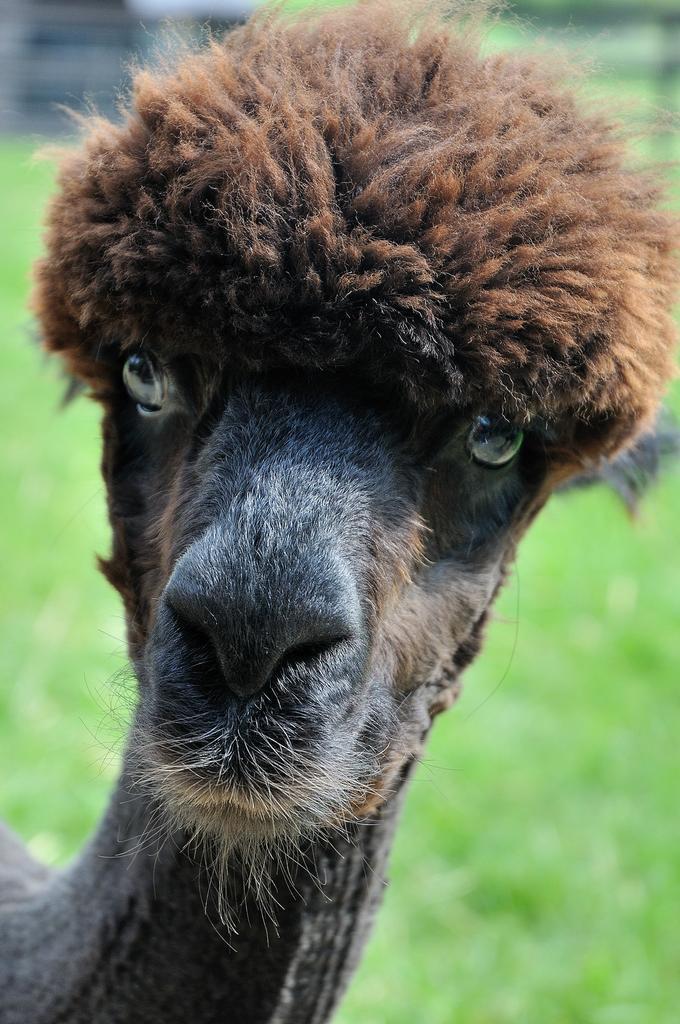Describe this image in one or two sentences. In this image I can see an animal in brown color. Background I can see grass in green color. 